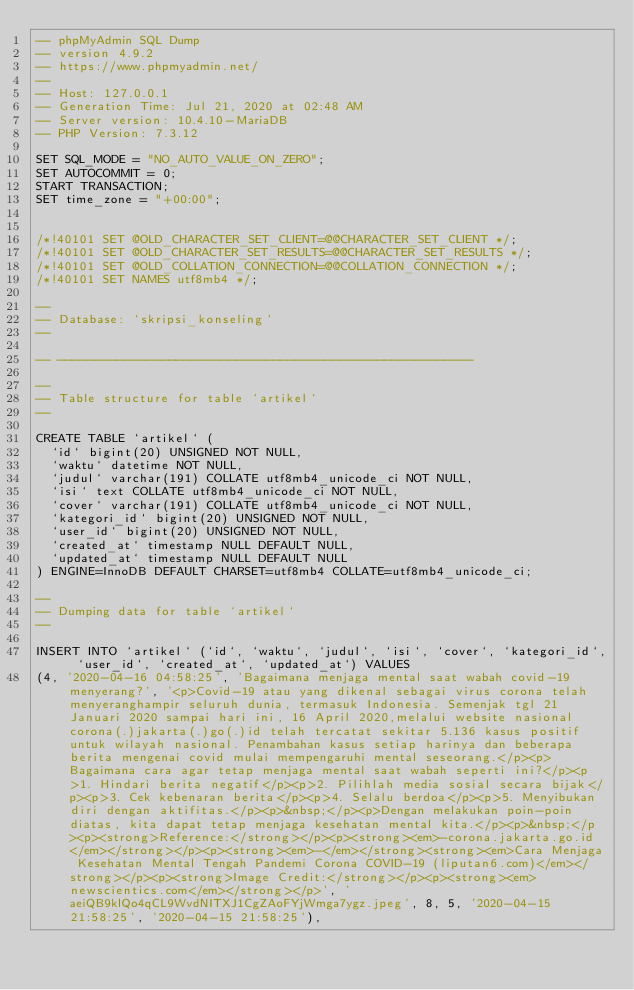<code> <loc_0><loc_0><loc_500><loc_500><_SQL_>-- phpMyAdmin SQL Dump
-- version 4.9.2
-- https://www.phpmyadmin.net/
--
-- Host: 127.0.0.1
-- Generation Time: Jul 21, 2020 at 02:48 AM
-- Server version: 10.4.10-MariaDB
-- PHP Version: 7.3.12

SET SQL_MODE = "NO_AUTO_VALUE_ON_ZERO";
SET AUTOCOMMIT = 0;
START TRANSACTION;
SET time_zone = "+00:00";


/*!40101 SET @OLD_CHARACTER_SET_CLIENT=@@CHARACTER_SET_CLIENT */;
/*!40101 SET @OLD_CHARACTER_SET_RESULTS=@@CHARACTER_SET_RESULTS */;
/*!40101 SET @OLD_COLLATION_CONNECTION=@@COLLATION_CONNECTION */;
/*!40101 SET NAMES utf8mb4 */;

--
-- Database: `skripsi_konseling`
--

-- --------------------------------------------------------

--
-- Table structure for table `artikel`
--

CREATE TABLE `artikel` (
  `id` bigint(20) UNSIGNED NOT NULL,
  `waktu` datetime NOT NULL,
  `judul` varchar(191) COLLATE utf8mb4_unicode_ci NOT NULL,
  `isi` text COLLATE utf8mb4_unicode_ci NOT NULL,
  `cover` varchar(191) COLLATE utf8mb4_unicode_ci NOT NULL,
  `kategori_id` bigint(20) UNSIGNED NOT NULL,
  `user_id` bigint(20) UNSIGNED NOT NULL,
  `created_at` timestamp NULL DEFAULT NULL,
  `updated_at` timestamp NULL DEFAULT NULL
) ENGINE=InnoDB DEFAULT CHARSET=utf8mb4 COLLATE=utf8mb4_unicode_ci;

--
-- Dumping data for table `artikel`
--

INSERT INTO `artikel` (`id`, `waktu`, `judul`, `isi`, `cover`, `kategori_id`, `user_id`, `created_at`, `updated_at`) VALUES
(4, '2020-04-16 04:58:25', 'Bagaimana menjaga mental saat wabah covid-19 menyerang?', '<p>Covid-19 atau yang dikenal sebagai virus corona telah menyeranghampir seluruh dunia, termasuk Indonesia. Semenjak tgl 21 Januari 2020 sampai hari ini, 16 April 2020,melalui website nasional corona(.)jakarta(.)go(.)id telah tercatat sekitar 5.136 kasus positif untuk wilayah nasional. Penambahan kasus setiap harinya dan beberapa berita mengenai covid mulai mempengaruhi mental seseorang.</p><p>Bagaimana cara agar tetap menjaga mental saat wabah seperti ini?</p><p>1. Hindari berita negatif</p><p>2. Pilihlah media sosial secara bijak</p><p>3. Cek kebenaran berita</p><p>4. Selalu berdoa</p><p>5. Menyibukan diri dengan aktifitas.</p><p>&nbsp;</p><p>Dengan melakukan poin-poin diatas, kita dapat tetap menjaga kesehatan mental kita.</p><p>&nbsp;</p><p><strong>Reference:</strong></p><p><strong><em>-corona.jakarta.go.id</em></strong></p><p><strong><em>-</em></strong><strong><em>Cara Menjaga Kesehatan Mental Tengah Pandemi Corona COVID-19 (liputan6.com)</em></strong></p><p><strong>Image Credit:</strong></p><p><strong><em>newscientics.com</em></strong></p>', 'aeiQB9klQo4qCL9WvdNITXJ1CgZAoFYjWmga7ygz.jpeg', 8, 5, '2020-04-15 21:58:25', '2020-04-15 21:58:25'),</code> 